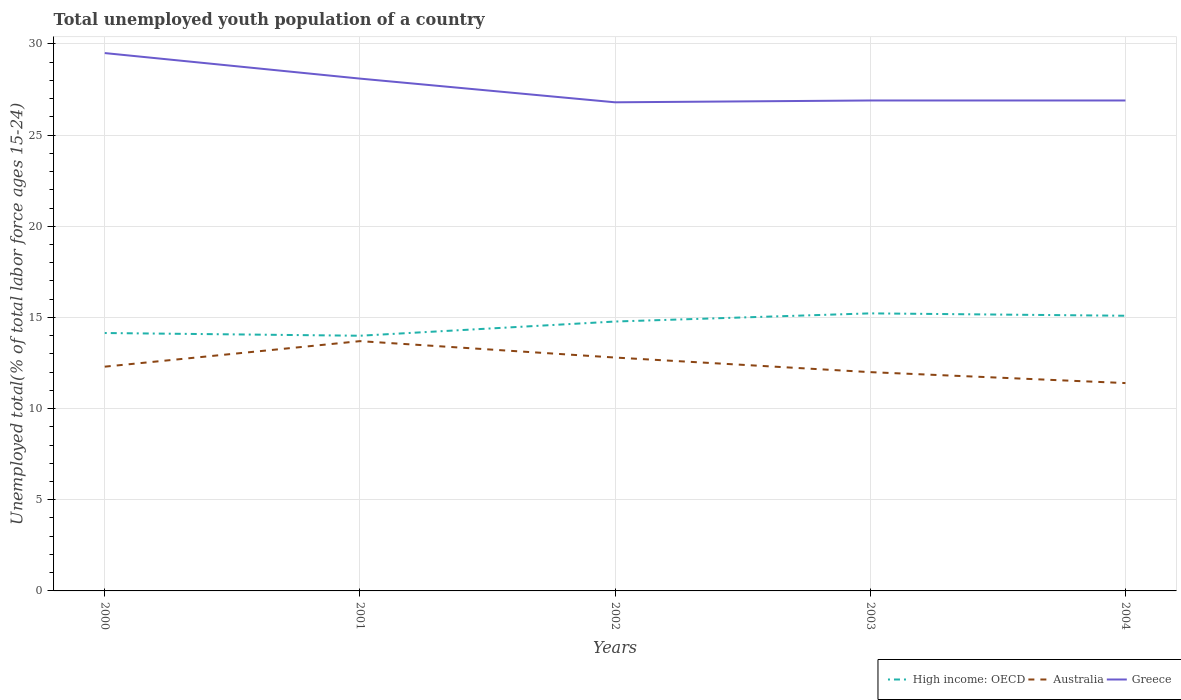How many different coloured lines are there?
Provide a short and direct response. 3. Is the number of lines equal to the number of legend labels?
Your answer should be very brief. Yes. Across all years, what is the maximum percentage of total unemployed youth population of a country in High income: OECD?
Make the answer very short. 14. What is the total percentage of total unemployed youth population of a country in Greece in the graph?
Provide a short and direct response. -0.1. What is the difference between the highest and the second highest percentage of total unemployed youth population of a country in High income: OECD?
Provide a succinct answer. 1.23. What is the difference between the highest and the lowest percentage of total unemployed youth population of a country in Australia?
Your answer should be compact. 2. How many years are there in the graph?
Your answer should be compact. 5. What is the difference between two consecutive major ticks on the Y-axis?
Your response must be concise. 5. Are the values on the major ticks of Y-axis written in scientific E-notation?
Offer a very short reply. No. Does the graph contain any zero values?
Provide a short and direct response. No. How are the legend labels stacked?
Your answer should be very brief. Horizontal. What is the title of the graph?
Your answer should be very brief. Total unemployed youth population of a country. What is the label or title of the Y-axis?
Offer a terse response. Unemployed total(% of total labor force ages 15-24). What is the Unemployed total(% of total labor force ages 15-24) of High income: OECD in 2000?
Your answer should be very brief. 14.15. What is the Unemployed total(% of total labor force ages 15-24) of Australia in 2000?
Your response must be concise. 12.3. What is the Unemployed total(% of total labor force ages 15-24) in Greece in 2000?
Provide a succinct answer. 29.5. What is the Unemployed total(% of total labor force ages 15-24) of High income: OECD in 2001?
Your response must be concise. 14. What is the Unemployed total(% of total labor force ages 15-24) in Australia in 2001?
Your answer should be very brief. 13.7. What is the Unemployed total(% of total labor force ages 15-24) of Greece in 2001?
Your answer should be very brief. 28.1. What is the Unemployed total(% of total labor force ages 15-24) in High income: OECD in 2002?
Provide a succinct answer. 14.78. What is the Unemployed total(% of total labor force ages 15-24) in Australia in 2002?
Your answer should be very brief. 12.8. What is the Unemployed total(% of total labor force ages 15-24) of Greece in 2002?
Give a very brief answer. 26.8. What is the Unemployed total(% of total labor force ages 15-24) in High income: OECD in 2003?
Provide a short and direct response. 15.22. What is the Unemployed total(% of total labor force ages 15-24) of Greece in 2003?
Ensure brevity in your answer.  26.9. What is the Unemployed total(% of total labor force ages 15-24) in High income: OECD in 2004?
Offer a very short reply. 15.09. What is the Unemployed total(% of total labor force ages 15-24) of Australia in 2004?
Give a very brief answer. 11.4. What is the Unemployed total(% of total labor force ages 15-24) of Greece in 2004?
Provide a succinct answer. 26.9. Across all years, what is the maximum Unemployed total(% of total labor force ages 15-24) of High income: OECD?
Offer a terse response. 15.22. Across all years, what is the maximum Unemployed total(% of total labor force ages 15-24) in Australia?
Provide a succinct answer. 13.7. Across all years, what is the maximum Unemployed total(% of total labor force ages 15-24) of Greece?
Offer a very short reply. 29.5. Across all years, what is the minimum Unemployed total(% of total labor force ages 15-24) of High income: OECD?
Provide a succinct answer. 14. Across all years, what is the minimum Unemployed total(% of total labor force ages 15-24) of Australia?
Make the answer very short. 11.4. Across all years, what is the minimum Unemployed total(% of total labor force ages 15-24) of Greece?
Your response must be concise. 26.8. What is the total Unemployed total(% of total labor force ages 15-24) in High income: OECD in the graph?
Offer a very short reply. 73.23. What is the total Unemployed total(% of total labor force ages 15-24) in Australia in the graph?
Provide a short and direct response. 62.2. What is the total Unemployed total(% of total labor force ages 15-24) of Greece in the graph?
Your response must be concise. 138.2. What is the difference between the Unemployed total(% of total labor force ages 15-24) in High income: OECD in 2000 and that in 2001?
Keep it short and to the point. 0.15. What is the difference between the Unemployed total(% of total labor force ages 15-24) of Australia in 2000 and that in 2001?
Give a very brief answer. -1.4. What is the difference between the Unemployed total(% of total labor force ages 15-24) in Greece in 2000 and that in 2001?
Keep it short and to the point. 1.4. What is the difference between the Unemployed total(% of total labor force ages 15-24) in High income: OECD in 2000 and that in 2002?
Ensure brevity in your answer.  -0.63. What is the difference between the Unemployed total(% of total labor force ages 15-24) in Greece in 2000 and that in 2002?
Provide a short and direct response. 2.7. What is the difference between the Unemployed total(% of total labor force ages 15-24) in High income: OECD in 2000 and that in 2003?
Keep it short and to the point. -1.08. What is the difference between the Unemployed total(% of total labor force ages 15-24) of Australia in 2000 and that in 2003?
Your answer should be compact. 0.3. What is the difference between the Unemployed total(% of total labor force ages 15-24) of High income: OECD in 2000 and that in 2004?
Provide a succinct answer. -0.95. What is the difference between the Unemployed total(% of total labor force ages 15-24) in High income: OECD in 2001 and that in 2002?
Make the answer very short. -0.78. What is the difference between the Unemployed total(% of total labor force ages 15-24) of High income: OECD in 2001 and that in 2003?
Your answer should be compact. -1.23. What is the difference between the Unemployed total(% of total labor force ages 15-24) in Australia in 2001 and that in 2003?
Offer a terse response. 1.7. What is the difference between the Unemployed total(% of total labor force ages 15-24) of High income: OECD in 2001 and that in 2004?
Offer a terse response. -1.1. What is the difference between the Unemployed total(% of total labor force ages 15-24) of High income: OECD in 2002 and that in 2003?
Your response must be concise. -0.45. What is the difference between the Unemployed total(% of total labor force ages 15-24) in Greece in 2002 and that in 2003?
Give a very brief answer. -0.1. What is the difference between the Unemployed total(% of total labor force ages 15-24) in High income: OECD in 2002 and that in 2004?
Make the answer very short. -0.32. What is the difference between the Unemployed total(% of total labor force ages 15-24) of Greece in 2002 and that in 2004?
Make the answer very short. -0.1. What is the difference between the Unemployed total(% of total labor force ages 15-24) in High income: OECD in 2003 and that in 2004?
Provide a short and direct response. 0.13. What is the difference between the Unemployed total(% of total labor force ages 15-24) in Australia in 2003 and that in 2004?
Offer a terse response. 0.6. What is the difference between the Unemployed total(% of total labor force ages 15-24) of High income: OECD in 2000 and the Unemployed total(% of total labor force ages 15-24) of Australia in 2001?
Your answer should be compact. 0.45. What is the difference between the Unemployed total(% of total labor force ages 15-24) of High income: OECD in 2000 and the Unemployed total(% of total labor force ages 15-24) of Greece in 2001?
Make the answer very short. -13.95. What is the difference between the Unemployed total(% of total labor force ages 15-24) in Australia in 2000 and the Unemployed total(% of total labor force ages 15-24) in Greece in 2001?
Ensure brevity in your answer.  -15.8. What is the difference between the Unemployed total(% of total labor force ages 15-24) in High income: OECD in 2000 and the Unemployed total(% of total labor force ages 15-24) in Australia in 2002?
Your response must be concise. 1.35. What is the difference between the Unemployed total(% of total labor force ages 15-24) in High income: OECD in 2000 and the Unemployed total(% of total labor force ages 15-24) in Greece in 2002?
Your answer should be compact. -12.65. What is the difference between the Unemployed total(% of total labor force ages 15-24) of High income: OECD in 2000 and the Unemployed total(% of total labor force ages 15-24) of Australia in 2003?
Your response must be concise. 2.15. What is the difference between the Unemployed total(% of total labor force ages 15-24) in High income: OECD in 2000 and the Unemployed total(% of total labor force ages 15-24) in Greece in 2003?
Keep it short and to the point. -12.75. What is the difference between the Unemployed total(% of total labor force ages 15-24) in Australia in 2000 and the Unemployed total(% of total labor force ages 15-24) in Greece in 2003?
Your answer should be very brief. -14.6. What is the difference between the Unemployed total(% of total labor force ages 15-24) of High income: OECD in 2000 and the Unemployed total(% of total labor force ages 15-24) of Australia in 2004?
Give a very brief answer. 2.75. What is the difference between the Unemployed total(% of total labor force ages 15-24) in High income: OECD in 2000 and the Unemployed total(% of total labor force ages 15-24) in Greece in 2004?
Give a very brief answer. -12.75. What is the difference between the Unemployed total(% of total labor force ages 15-24) in Australia in 2000 and the Unemployed total(% of total labor force ages 15-24) in Greece in 2004?
Your answer should be very brief. -14.6. What is the difference between the Unemployed total(% of total labor force ages 15-24) of High income: OECD in 2001 and the Unemployed total(% of total labor force ages 15-24) of Australia in 2002?
Provide a succinct answer. 1.2. What is the difference between the Unemployed total(% of total labor force ages 15-24) of High income: OECD in 2001 and the Unemployed total(% of total labor force ages 15-24) of Greece in 2002?
Make the answer very short. -12.8. What is the difference between the Unemployed total(% of total labor force ages 15-24) of Australia in 2001 and the Unemployed total(% of total labor force ages 15-24) of Greece in 2002?
Give a very brief answer. -13.1. What is the difference between the Unemployed total(% of total labor force ages 15-24) in High income: OECD in 2001 and the Unemployed total(% of total labor force ages 15-24) in Australia in 2003?
Your answer should be compact. 2. What is the difference between the Unemployed total(% of total labor force ages 15-24) of High income: OECD in 2001 and the Unemployed total(% of total labor force ages 15-24) of Greece in 2003?
Ensure brevity in your answer.  -12.9. What is the difference between the Unemployed total(% of total labor force ages 15-24) in Australia in 2001 and the Unemployed total(% of total labor force ages 15-24) in Greece in 2003?
Give a very brief answer. -13.2. What is the difference between the Unemployed total(% of total labor force ages 15-24) of High income: OECD in 2001 and the Unemployed total(% of total labor force ages 15-24) of Australia in 2004?
Your response must be concise. 2.6. What is the difference between the Unemployed total(% of total labor force ages 15-24) in High income: OECD in 2001 and the Unemployed total(% of total labor force ages 15-24) in Greece in 2004?
Ensure brevity in your answer.  -12.9. What is the difference between the Unemployed total(% of total labor force ages 15-24) of High income: OECD in 2002 and the Unemployed total(% of total labor force ages 15-24) of Australia in 2003?
Offer a very short reply. 2.78. What is the difference between the Unemployed total(% of total labor force ages 15-24) of High income: OECD in 2002 and the Unemployed total(% of total labor force ages 15-24) of Greece in 2003?
Make the answer very short. -12.12. What is the difference between the Unemployed total(% of total labor force ages 15-24) of Australia in 2002 and the Unemployed total(% of total labor force ages 15-24) of Greece in 2003?
Give a very brief answer. -14.1. What is the difference between the Unemployed total(% of total labor force ages 15-24) in High income: OECD in 2002 and the Unemployed total(% of total labor force ages 15-24) in Australia in 2004?
Your response must be concise. 3.38. What is the difference between the Unemployed total(% of total labor force ages 15-24) in High income: OECD in 2002 and the Unemployed total(% of total labor force ages 15-24) in Greece in 2004?
Provide a short and direct response. -12.12. What is the difference between the Unemployed total(% of total labor force ages 15-24) of Australia in 2002 and the Unemployed total(% of total labor force ages 15-24) of Greece in 2004?
Provide a short and direct response. -14.1. What is the difference between the Unemployed total(% of total labor force ages 15-24) in High income: OECD in 2003 and the Unemployed total(% of total labor force ages 15-24) in Australia in 2004?
Ensure brevity in your answer.  3.82. What is the difference between the Unemployed total(% of total labor force ages 15-24) in High income: OECD in 2003 and the Unemployed total(% of total labor force ages 15-24) in Greece in 2004?
Your response must be concise. -11.68. What is the difference between the Unemployed total(% of total labor force ages 15-24) of Australia in 2003 and the Unemployed total(% of total labor force ages 15-24) of Greece in 2004?
Provide a succinct answer. -14.9. What is the average Unemployed total(% of total labor force ages 15-24) of High income: OECD per year?
Provide a succinct answer. 14.65. What is the average Unemployed total(% of total labor force ages 15-24) of Australia per year?
Offer a terse response. 12.44. What is the average Unemployed total(% of total labor force ages 15-24) of Greece per year?
Your response must be concise. 27.64. In the year 2000, what is the difference between the Unemployed total(% of total labor force ages 15-24) in High income: OECD and Unemployed total(% of total labor force ages 15-24) in Australia?
Ensure brevity in your answer.  1.85. In the year 2000, what is the difference between the Unemployed total(% of total labor force ages 15-24) of High income: OECD and Unemployed total(% of total labor force ages 15-24) of Greece?
Make the answer very short. -15.35. In the year 2000, what is the difference between the Unemployed total(% of total labor force ages 15-24) in Australia and Unemployed total(% of total labor force ages 15-24) in Greece?
Keep it short and to the point. -17.2. In the year 2001, what is the difference between the Unemployed total(% of total labor force ages 15-24) of High income: OECD and Unemployed total(% of total labor force ages 15-24) of Australia?
Keep it short and to the point. 0.3. In the year 2001, what is the difference between the Unemployed total(% of total labor force ages 15-24) of High income: OECD and Unemployed total(% of total labor force ages 15-24) of Greece?
Provide a short and direct response. -14.1. In the year 2001, what is the difference between the Unemployed total(% of total labor force ages 15-24) in Australia and Unemployed total(% of total labor force ages 15-24) in Greece?
Offer a terse response. -14.4. In the year 2002, what is the difference between the Unemployed total(% of total labor force ages 15-24) of High income: OECD and Unemployed total(% of total labor force ages 15-24) of Australia?
Your answer should be very brief. 1.98. In the year 2002, what is the difference between the Unemployed total(% of total labor force ages 15-24) in High income: OECD and Unemployed total(% of total labor force ages 15-24) in Greece?
Provide a succinct answer. -12.02. In the year 2002, what is the difference between the Unemployed total(% of total labor force ages 15-24) of Australia and Unemployed total(% of total labor force ages 15-24) of Greece?
Offer a terse response. -14. In the year 2003, what is the difference between the Unemployed total(% of total labor force ages 15-24) in High income: OECD and Unemployed total(% of total labor force ages 15-24) in Australia?
Ensure brevity in your answer.  3.22. In the year 2003, what is the difference between the Unemployed total(% of total labor force ages 15-24) in High income: OECD and Unemployed total(% of total labor force ages 15-24) in Greece?
Offer a terse response. -11.68. In the year 2003, what is the difference between the Unemployed total(% of total labor force ages 15-24) of Australia and Unemployed total(% of total labor force ages 15-24) of Greece?
Provide a short and direct response. -14.9. In the year 2004, what is the difference between the Unemployed total(% of total labor force ages 15-24) in High income: OECD and Unemployed total(% of total labor force ages 15-24) in Australia?
Ensure brevity in your answer.  3.69. In the year 2004, what is the difference between the Unemployed total(% of total labor force ages 15-24) in High income: OECD and Unemployed total(% of total labor force ages 15-24) in Greece?
Your answer should be compact. -11.81. In the year 2004, what is the difference between the Unemployed total(% of total labor force ages 15-24) in Australia and Unemployed total(% of total labor force ages 15-24) in Greece?
Offer a very short reply. -15.5. What is the ratio of the Unemployed total(% of total labor force ages 15-24) in High income: OECD in 2000 to that in 2001?
Provide a short and direct response. 1.01. What is the ratio of the Unemployed total(% of total labor force ages 15-24) in Australia in 2000 to that in 2001?
Give a very brief answer. 0.9. What is the ratio of the Unemployed total(% of total labor force ages 15-24) in Greece in 2000 to that in 2001?
Your response must be concise. 1.05. What is the ratio of the Unemployed total(% of total labor force ages 15-24) of High income: OECD in 2000 to that in 2002?
Provide a succinct answer. 0.96. What is the ratio of the Unemployed total(% of total labor force ages 15-24) in Australia in 2000 to that in 2002?
Offer a very short reply. 0.96. What is the ratio of the Unemployed total(% of total labor force ages 15-24) in Greece in 2000 to that in 2002?
Give a very brief answer. 1.1. What is the ratio of the Unemployed total(% of total labor force ages 15-24) of High income: OECD in 2000 to that in 2003?
Offer a very short reply. 0.93. What is the ratio of the Unemployed total(% of total labor force ages 15-24) of Australia in 2000 to that in 2003?
Provide a short and direct response. 1.02. What is the ratio of the Unemployed total(% of total labor force ages 15-24) of Greece in 2000 to that in 2003?
Give a very brief answer. 1.1. What is the ratio of the Unemployed total(% of total labor force ages 15-24) of High income: OECD in 2000 to that in 2004?
Your answer should be very brief. 0.94. What is the ratio of the Unemployed total(% of total labor force ages 15-24) in Australia in 2000 to that in 2004?
Your answer should be compact. 1.08. What is the ratio of the Unemployed total(% of total labor force ages 15-24) in Greece in 2000 to that in 2004?
Make the answer very short. 1.1. What is the ratio of the Unemployed total(% of total labor force ages 15-24) in High income: OECD in 2001 to that in 2002?
Your answer should be compact. 0.95. What is the ratio of the Unemployed total(% of total labor force ages 15-24) of Australia in 2001 to that in 2002?
Your answer should be very brief. 1.07. What is the ratio of the Unemployed total(% of total labor force ages 15-24) of Greece in 2001 to that in 2002?
Your response must be concise. 1.05. What is the ratio of the Unemployed total(% of total labor force ages 15-24) of High income: OECD in 2001 to that in 2003?
Provide a short and direct response. 0.92. What is the ratio of the Unemployed total(% of total labor force ages 15-24) in Australia in 2001 to that in 2003?
Make the answer very short. 1.14. What is the ratio of the Unemployed total(% of total labor force ages 15-24) of Greece in 2001 to that in 2003?
Ensure brevity in your answer.  1.04. What is the ratio of the Unemployed total(% of total labor force ages 15-24) of High income: OECD in 2001 to that in 2004?
Keep it short and to the point. 0.93. What is the ratio of the Unemployed total(% of total labor force ages 15-24) in Australia in 2001 to that in 2004?
Offer a very short reply. 1.2. What is the ratio of the Unemployed total(% of total labor force ages 15-24) of Greece in 2001 to that in 2004?
Offer a very short reply. 1.04. What is the ratio of the Unemployed total(% of total labor force ages 15-24) of High income: OECD in 2002 to that in 2003?
Your answer should be very brief. 0.97. What is the ratio of the Unemployed total(% of total labor force ages 15-24) in Australia in 2002 to that in 2003?
Your answer should be compact. 1.07. What is the ratio of the Unemployed total(% of total labor force ages 15-24) of High income: OECD in 2002 to that in 2004?
Your response must be concise. 0.98. What is the ratio of the Unemployed total(% of total labor force ages 15-24) of Australia in 2002 to that in 2004?
Offer a terse response. 1.12. What is the ratio of the Unemployed total(% of total labor force ages 15-24) of Greece in 2002 to that in 2004?
Make the answer very short. 1. What is the ratio of the Unemployed total(% of total labor force ages 15-24) in High income: OECD in 2003 to that in 2004?
Your response must be concise. 1.01. What is the ratio of the Unemployed total(% of total labor force ages 15-24) in Australia in 2003 to that in 2004?
Your response must be concise. 1.05. What is the ratio of the Unemployed total(% of total labor force ages 15-24) of Greece in 2003 to that in 2004?
Your answer should be compact. 1. What is the difference between the highest and the second highest Unemployed total(% of total labor force ages 15-24) in High income: OECD?
Give a very brief answer. 0.13. What is the difference between the highest and the second highest Unemployed total(% of total labor force ages 15-24) in Greece?
Your answer should be very brief. 1.4. What is the difference between the highest and the lowest Unemployed total(% of total labor force ages 15-24) of High income: OECD?
Your answer should be compact. 1.23. 